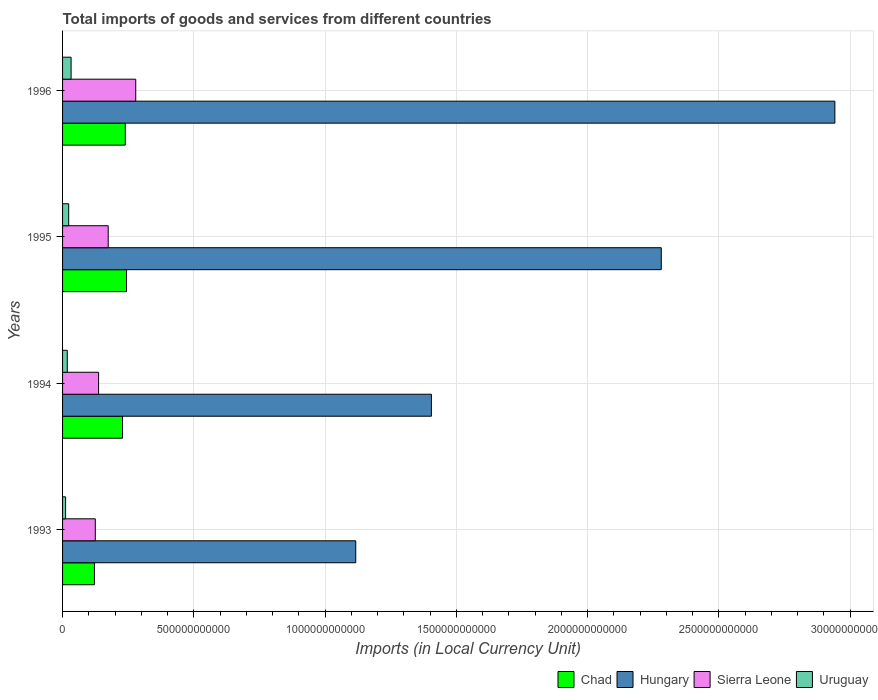How many groups of bars are there?
Provide a succinct answer. 4. Are the number of bars on each tick of the Y-axis equal?
Provide a short and direct response. Yes. How many bars are there on the 1st tick from the bottom?
Offer a terse response. 4. What is the label of the 3rd group of bars from the top?
Ensure brevity in your answer.  1994. What is the Amount of goods and services imports in Sierra Leone in 1993?
Keep it short and to the point. 1.25e+11. Across all years, what is the maximum Amount of goods and services imports in Chad?
Provide a short and direct response. 2.44e+11. Across all years, what is the minimum Amount of goods and services imports in Chad?
Your answer should be compact. 1.22e+11. In which year was the Amount of goods and services imports in Chad maximum?
Keep it short and to the point. 1995. What is the total Amount of goods and services imports in Chad in the graph?
Provide a short and direct response. 8.33e+11. What is the difference between the Amount of goods and services imports in Hungary in 1993 and that in 1995?
Offer a terse response. -1.16e+12. What is the difference between the Amount of goods and services imports in Hungary in 1996 and the Amount of goods and services imports in Uruguay in 1995?
Your answer should be very brief. 2.92e+12. What is the average Amount of goods and services imports in Uruguay per year?
Provide a succinct answer. 2.14e+1. In the year 1994, what is the difference between the Amount of goods and services imports in Uruguay and Amount of goods and services imports in Chad?
Provide a succinct answer. -2.11e+11. What is the ratio of the Amount of goods and services imports in Uruguay in 1994 to that in 1996?
Your answer should be compact. 0.55. Is the Amount of goods and services imports in Chad in 1994 less than that in 1996?
Your answer should be compact. Yes. What is the difference between the highest and the second highest Amount of goods and services imports in Chad?
Ensure brevity in your answer.  4.71e+09. What is the difference between the highest and the lowest Amount of goods and services imports in Uruguay?
Keep it short and to the point. 2.09e+1. In how many years, is the Amount of goods and services imports in Chad greater than the average Amount of goods and services imports in Chad taken over all years?
Your answer should be compact. 3. Is it the case that in every year, the sum of the Amount of goods and services imports in Sierra Leone and Amount of goods and services imports in Hungary is greater than the sum of Amount of goods and services imports in Chad and Amount of goods and services imports in Uruguay?
Make the answer very short. Yes. What does the 4th bar from the top in 1994 represents?
Provide a short and direct response. Chad. What does the 1st bar from the bottom in 1994 represents?
Ensure brevity in your answer.  Chad. What is the difference between two consecutive major ticks on the X-axis?
Provide a short and direct response. 5.00e+11. Does the graph contain any zero values?
Your response must be concise. No. Where does the legend appear in the graph?
Keep it short and to the point. Bottom right. How are the legend labels stacked?
Your answer should be very brief. Horizontal. What is the title of the graph?
Offer a very short reply. Total imports of goods and services from different countries. Does "Luxembourg" appear as one of the legend labels in the graph?
Your answer should be compact. No. What is the label or title of the X-axis?
Keep it short and to the point. Imports (in Local Currency Unit). What is the Imports (in Local Currency Unit) of Chad in 1993?
Your answer should be very brief. 1.22e+11. What is the Imports (in Local Currency Unit) in Hungary in 1993?
Ensure brevity in your answer.  1.12e+12. What is the Imports (in Local Currency Unit) in Sierra Leone in 1993?
Ensure brevity in your answer.  1.25e+11. What is the Imports (in Local Currency Unit) in Uruguay in 1993?
Offer a very short reply. 1.16e+1. What is the Imports (in Local Currency Unit) in Chad in 1994?
Ensure brevity in your answer.  2.28e+11. What is the Imports (in Local Currency Unit) in Hungary in 1994?
Your answer should be compact. 1.41e+12. What is the Imports (in Local Currency Unit) of Sierra Leone in 1994?
Your answer should be very brief. 1.37e+11. What is the Imports (in Local Currency Unit) in Uruguay in 1994?
Provide a short and direct response. 1.80e+1. What is the Imports (in Local Currency Unit) in Chad in 1995?
Provide a succinct answer. 2.44e+11. What is the Imports (in Local Currency Unit) of Hungary in 1995?
Keep it short and to the point. 2.28e+12. What is the Imports (in Local Currency Unit) of Sierra Leone in 1995?
Keep it short and to the point. 1.74e+11. What is the Imports (in Local Currency Unit) of Uruguay in 1995?
Give a very brief answer. 2.34e+1. What is the Imports (in Local Currency Unit) in Chad in 1996?
Your answer should be very brief. 2.39e+11. What is the Imports (in Local Currency Unit) in Hungary in 1996?
Your answer should be very brief. 2.94e+12. What is the Imports (in Local Currency Unit) of Sierra Leone in 1996?
Offer a very short reply. 2.79e+11. What is the Imports (in Local Currency Unit) in Uruguay in 1996?
Make the answer very short. 3.25e+1. Across all years, what is the maximum Imports (in Local Currency Unit) in Chad?
Give a very brief answer. 2.44e+11. Across all years, what is the maximum Imports (in Local Currency Unit) in Hungary?
Make the answer very short. 2.94e+12. Across all years, what is the maximum Imports (in Local Currency Unit) of Sierra Leone?
Make the answer very short. 2.79e+11. Across all years, what is the maximum Imports (in Local Currency Unit) in Uruguay?
Provide a short and direct response. 3.25e+1. Across all years, what is the minimum Imports (in Local Currency Unit) of Chad?
Ensure brevity in your answer.  1.22e+11. Across all years, what is the minimum Imports (in Local Currency Unit) in Hungary?
Make the answer very short. 1.12e+12. Across all years, what is the minimum Imports (in Local Currency Unit) of Sierra Leone?
Offer a very short reply. 1.25e+11. Across all years, what is the minimum Imports (in Local Currency Unit) in Uruguay?
Your answer should be very brief. 1.16e+1. What is the total Imports (in Local Currency Unit) of Chad in the graph?
Your answer should be very brief. 8.33e+11. What is the total Imports (in Local Currency Unit) in Hungary in the graph?
Ensure brevity in your answer.  7.75e+12. What is the total Imports (in Local Currency Unit) of Sierra Leone in the graph?
Ensure brevity in your answer.  7.15e+11. What is the total Imports (in Local Currency Unit) of Uruguay in the graph?
Offer a very short reply. 8.54e+1. What is the difference between the Imports (in Local Currency Unit) in Chad in 1993 and that in 1994?
Make the answer very short. -1.07e+11. What is the difference between the Imports (in Local Currency Unit) in Hungary in 1993 and that in 1994?
Give a very brief answer. -2.88e+11. What is the difference between the Imports (in Local Currency Unit) of Sierra Leone in 1993 and that in 1994?
Offer a terse response. -1.25e+1. What is the difference between the Imports (in Local Currency Unit) of Uruguay in 1993 and that in 1994?
Provide a succinct answer. -6.40e+09. What is the difference between the Imports (in Local Currency Unit) of Chad in 1993 and that in 1995?
Offer a terse response. -1.22e+11. What is the difference between the Imports (in Local Currency Unit) of Hungary in 1993 and that in 1995?
Provide a short and direct response. -1.16e+12. What is the difference between the Imports (in Local Currency Unit) of Sierra Leone in 1993 and that in 1995?
Give a very brief answer. -4.92e+1. What is the difference between the Imports (in Local Currency Unit) in Uruguay in 1993 and that in 1995?
Keep it short and to the point. -1.18e+1. What is the difference between the Imports (in Local Currency Unit) of Chad in 1993 and that in 1996?
Provide a short and direct response. -1.17e+11. What is the difference between the Imports (in Local Currency Unit) in Hungary in 1993 and that in 1996?
Your answer should be very brief. -1.83e+12. What is the difference between the Imports (in Local Currency Unit) of Sierra Leone in 1993 and that in 1996?
Your answer should be compact. -1.54e+11. What is the difference between the Imports (in Local Currency Unit) in Uruguay in 1993 and that in 1996?
Make the answer very short. -2.09e+1. What is the difference between the Imports (in Local Currency Unit) in Chad in 1994 and that in 1995?
Offer a terse response. -1.52e+1. What is the difference between the Imports (in Local Currency Unit) in Hungary in 1994 and that in 1995?
Ensure brevity in your answer.  -8.76e+11. What is the difference between the Imports (in Local Currency Unit) of Sierra Leone in 1994 and that in 1995?
Offer a very short reply. -3.66e+1. What is the difference between the Imports (in Local Currency Unit) in Uruguay in 1994 and that in 1995?
Your answer should be compact. -5.44e+09. What is the difference between the Imports (in Local Currency Unit) in Chad in 1994 and that in 1996?
Your response must be concise. -1.05e+1. What is the difference between the Imports (in Local Currency Unit) in Hungary in 1994 and that in 1996?
Your response must be concise. -1.54e+12. What is the difference between the Imports (in Local Currency Unit) of Sierra Leone in 1994 and that in 1996?
Your answer should be compact. -1.42e+11. What is the difference between the Imports (in Local Currency Unit) in Uruguay in 1994 and that in 1996?
Make the answer very short. -1.45e+1. What is the difference between the Imports (in Local Currency Unit) in Chad in 1995 and that in 1996?
Provide a short and direct response. 4.71e+09. What is the difference between the Imports (in Local Currency Unit) of Hungary in 1995 and that in 1996?
Your answer should be compact. -6.61e+11. What is the difference between the Imports (in Local Currency Unit) of Sierra Leone in 1995 and that in 1996?
Offer a terse response. -1.05e+11. What is the difference between the Imports (in Local Currency Unit) in Uruguay in 1995 and that in 1996?
Ensure brevity in your answer.  -9.08e+09. What is the difference between the Imports (in Local Currency Unit) of Chad in 1993 and the Imports (in Local Currency Unit) of Hungary in 1994?
Your answer should be very brief. -1.28e+12. What is the difference between the Imports (in Local Currency Unit) of Chad in 1993 and the Imports (in Local Currency Unit) of Sierra Leone in 1994?
Your response must be concise. -1.57e+1. What is the difference between the Imports (in Local Currency Unit) in Chad in 1993 and the Imports (in Local Currency Unit) in Uruguay in 1994?
Make the answer very short. 1.04e+11. What is the difference between the Imports (in Local Currency Unit) in Hungary in 1993 and the Imports (in Local Currency Unit) in Sierra Leone in 1994?
Ensure brevity in your answer.  9.80e+11. What is the difference between the Imports (in Local Currency Unit) in Hungary in 1993 and the Imports (in Local Currency Unit) in Uruguay in 1994?
Your answer should be very brief. 1.10e+12. What is the difference between the Imports (in Local Currency Unit) of Sierra Leone in 1993 and the Imports (in Local Currency Unit) of Uruguay in 1994?
Your answer should be very brief. 1.07e+11. What is the difference between the Imports (in Local Currency Unit) in Chad in 1993 and the Imports (in Local Currency Unit) in Hungary in 1995?
Offer a terse response. -2.16e+12. What is the difference between the Imports (in Local Currency Unit) of Chad in 1993 and the Imports (in Local Currency Unit) of Sierra Leone in 1995?
Give a very brief answer. -5.24e+1. What is the difference between the Imports (in Local Currency Unit) of Chad in 1993 and the Imports (in Local Currency Unit) of Uruguay in 1995?
Offer a terse response. 9.81e+1. What is the difference between the Imports (in Local Currency Unit) of Hungary in 1993 and the Imports (in Local Currency Unit) of Sierra Leone in 1995?
Ensure brevity in your answer.  9.43e+11. What is the difference between the Imports (in Local Currency Unit) in Hungary in 1993 and the Imports (in Local Currency Unit) in Uruguay in 1995?
Your response must be concise. 1.09e+12. What is the difference between the Imports (in Local Currency Unit) in Sierra Leone in 1993 and the Imports (in Local Currency Unit) in Uruguay in 1995?
Make the answer very short. 1.01e+11. What is the difference between the Imports (in Local Currency Unit) of Chad in 1993 and the Imports (in Local Currency Unit) of Hungary in 1996?
Your response must be concise. -2.82e+12. What is the difference between the Imports (in Local Currency Unit) in Chad in 1993 and the Imports (in Local Currency Unit) in Sierra Leone in 1996?
Your answer should be very brief. -1.57e+11. What is the difference between the Imports (in Local Currency Unit) in Chad in 1993 and the Imports (in Local Currency Unit) in Uruguay in 1996?
Keep it short and to the point. 8.90e+1. What is the difference between the Imports (in Local Currency Unit) in Hungary in 1993 and the Imports (in Local Currency Unit) in Sierra Leone in 1996?
Your answer should be very brief. 8.38e+11. What is the difference between the Imports (in Local Currency Unit) in Hungary in 1993 and the Imports (in Local Currency Unit) in Uruguay in 1996?
Offer a terse response. 1.08e+12. What is the difference between the Imports (in Local Currency Unit) of Sierra Leone in 1993 and the Imports (in Local Currency Unit) of Uruguay in 1996?
Provide a short and direct response. 9.22e+1. What is the difference between the Imports (in Local Currency Unit) of Chad in 1994 and the Imports (in Local Currency Unit) of Hungary in 1995?
Your answer should be very brief. -2.05e+12. What is the difference between the Imports (in Local Currency Unit) of Chad in 1994 and the Imports (in Local Currency Unit) of Sierra Leone in 1995?
Give a very brief answer. 5.46e+1. What is the difference between the Imports (in Local Currency Unit) of Chad in 1994 and the Imports (in Local Currency Unit) of Uruguay in 1995?
Give a very brief answer. 2.05e+11. What is the difference between the Imports (in Local Currency Unit) in Hungary in 1994 and the Imports (in Local Currency Unit) in Sierra Leone in 1995?
Provide a succinct answer. 1.23e+12. What is the difference between the Imports (in Local Currency Unit) of Hungary in 1994 and the Imports (in Local Currency Unit) of Uruguay in 1995?
Make the answer very short. 1.38e+12. What is the difference between the Imports (in Local Currency Unit) of Sierra Leone in 1994 and the Imports (in Local Currency Unit) of Uruguay in 1995?
Keep it short and to the point. 1.14e+11. What is the difference between the Imports (in Local Currency Unit) in Chad in 1994 and the Imports (in Local Currency Unit) in Hungary in 1996?
Provide a short and direct response. -2.71e+12. What is the difference between the Imports (in Local Currency Unit) in Chad in 1994 and the Imports (in Local Currency Unit) in Sierra Leone in 1996?
Offer a terse response. -5.03e+1. What is the difference between the Imports (in Local Currency Unit) of Chad in 1994 and the Imports (in Local Currency Unit) of Uruguay in 1996?
Provide a short and direct response. 1.96e+11. What is the difference between the Imports (in Local Currency Unit) of Hungary in 1994 and the Imports (in Local Currency Unit) of Sierra Leone in 1996?
Ensure brevity in your answer.  1.13e+12. What is the difference between the Imports (in Local Currency Unit) in Hungary in 1994 and the Imports (in Local Currency Unit) in Uruguay in 1996?
Ensure brevity in your answer.  1.37e+12. What is the difference between the Imports (in Local Currency Unit) of Sierra Leone in 1994 and the Imports (in Local Currency Unit) of Uruguay in 1996?
Keep it short and to the point. 1.05e+11. What is the difference between the Imports (in Local Currency Unit) in Chad in 1995 and the Imports (in Local Currency Unit) in Hungary in 1996?
Provide a short and direct response. -2.70e+12. What is the difference between the Imports (in Local Currency Unit) in Chad in 1995 and the Imports (in Local Currency Unit) in Sierra Leone in 1996?
Make the answer very short. -3.51e+1. What is the difference between the Imports (in Local Currency Unit) in Chad in 1995 and the Imports (in Local Currency Unit) in Uruguay in 1996?
Provide a short and direct response. 2.11e+11. What is the difference between the Imports (in Local Currency Unit) of Hungary in 1995 and the Imports (in Local Currency Unit) of Sierra Leone in 1996?
Offer a terse response. 2.00e+12. What is the difference between the Imports (in Local Currency Unit) of Hungary in 1995 and the Imports (in Local Currency Unit) of Uruguay in 1996?
Keep it short and to the point. 2.25e+12. What is the difference between the Imports (in Local Currency Unit) in Sierra Leone in 1995 and the Imports (in Local Currency Unit) in Uruguay in 1996?
Keep it short and to the point. 1.41e+11. What is the average Imports (in Local Currency Unit) in Chad per year?
Your response must be concise. 2.08e+11. What is the average Imports (in Local Currency Unit) of Hungary per year?
Give a very brief answer. 1.94e+12. What is the average Imports (in Local Currency Unit) in Sierra Leone per year?
Offer a terse response. 1.79e+11. What is the average Imports (in Local Currency Unit) of Uruguay per year?
Your answer should be compact. 2.14e+1. In the year 1993, what is the difference between the Imports (in Local Currency Unit) in Chad and Imports (in Local Currency Unit) in Hungary?
Give a very brief answer. -9.95e+11. In the year 1993, what is the difference between the Imports (in Local Currency Unit) of Chad and Imports (in Local Currency Unit) of Sierra Leone?
Provide a succinct answer. -3.18e+09. In the year 1993, what is the difference between the Imports (in Local Currency Unit) of Chad and Imports (in Local Currency Unit) of Uruguay?
Keep it short and to the point. 1.10e+11. In the year 1993, what is the difference between the Imports (in Local Currency Unit) in Hungary and Imports (in Local Currency Unit) in Sierra Leone?
Provide a short and direct response. 9.92e+11. In the year 1993, what is the difference between the Imports (in Local Currency Unit) in Hungary and Imports (in Local Currency Unit) in Uruguay?
Provide a short and direct response. 1.11e+12. In the year 1993, what is the difference between the Imports (in Local Currency Unit) of Sierra Leone and Imports (in Local Currency Unit) of Uruguay?
Offer a very short reply. 1.13e+11. In the year 1994, what is the difference between the Imports (in Local Currency Unit) in Chad and Imports (in Local Currency Unit) in Hungary?
Your response must be concise. -1.18e+12. In the year 1994, what is the difference between the Imports (in Local Currency Unit) in Chad and Imports (in Local Currency Unit) in Sierra Leone?
Keep it short and to the point. 9.13e+1. In the year 1994, what is the difference between the Imports (in Local Currency Unit) of Chad and Imports (in Local Currency Unit) of Uruguay?
Offer a terse response. 2.11e+11. In the year 1994, what is the difference between the Imports (in Local Currency Unit) in Hungary and Imports (in Local Currency Unit) in Sierra Leone?
Provide a short and direct response. 1.27e+12. In the year 1994, what is the difference between the Imports (in Local Currency Unit) of Hungary and Imports (in Local Currency Unit) of Uruguay?
Your response must be concise. 1.39e+12. In the year 1994, what is the difference between the Imports (in Local Currency Unit) in Sierra Leone and Imports (in Local Currency Unit) in Uruguay?
Provide a short and direct response. 1.19e+11. In the year 1995, what is the difference between the Imports (in Local Currency Unit) of Chad and Imports (in Local Currency Unit) of Hungary?
Provide a succinct answer. -2.04e+12. In the year 1995, what is the difference between the Imports (in Local Currency Unit) in Chad and Imports (in Local Currency Unit) in Sierra Leone?
Your answer should be compact. 6.98e+1. In the year 1995, what is the difference between the Imports (in Local Currency Unit) in Chad and Imports (in Local Currency Unit) in Uruguay?
Keep it short and to the point. 2.20e+11. In the year 1995, what is the difference between the Imports (in Local Currency Unit) in Hungary and Imports (in Local Currency Unit) in Sierra Leone?
Offer a very short reply. 2.11e+12. In the year 1995, what is the difference between the Imports (in Local Currency Unit) in Hungary and Imports (in Local Currency Unit) in Uruguay?
Your response must be concise. 2.26e+12. In the year 1995, what is the difference between the Imports (in Local Currency Unit) in Sierra Leone and Imports (in Local Currency Unit) in Uruguay?
Offer a very short reply. 1.50e+11. In the year 1996, what is the difference between the Imports (in Local Currency Unit) of Chad and Imports (in Local Currency Unit) of Hungary?
Provide a short and direct response. -2.70e+12. In the year 1996, what is the difference between the Imports (in Local Currency Unit) in Chad and Imports (in Local Currency Unit) in Sierra Leone?
Keep it short and to the point. -3.98e+1. In the year 1996, what is the difference between the Imports (in Local Currency Unit) in Chad and Imports (in Local Currency Unit) in Uruguay?
Offer a terse response. 2.07e+11. In the year 1996, what is the difference between the Imports (in Local Currency Unit) of Hungary and Imports (in Local Currency Unit) of Sierra Leone?
Your answer should be compact. 2.66e+12. In the year 1996, what is the difference between the Imports (in Local Currency Unit) of Hungary and Imports (in Local Currency Unit) of Uruguay?
Offer a terse response. 2.91e+12. In the year 1996, what is the difference between the Imports (in Local Currency Unit) of Sierra Leone and Imports (in Local Currency Unit) of Uruguay?
Your response must be concise. 2.46e+11. What is the ratio of the Imports (in Local Currency Unit) of Chad in 1993 to that in 1994?
Offer a very short reply. 0.53. What is the ratio of the Imports (in Local Currency Unit) of Hungary in 1993 to that in 1994?
Keep it short and to the point. 0.79. What is the ratio of the Imports (in Local Currency Unit) in Sierra Leone in 1993 to that in 1994?
Offer a terse response. 0.91. What is the ratio of the Imports (in Local Currency Unit) of Uruguay in 1993 to that in 1994?
Provide a short and direct response. 0.64. What is the ratio of the Imports (in Local Currency Unit) in Chad in 1993 to that in 1995?
Ensure brevity in your answer.  0.5. What is the ratio of the Imports (in Local Currency Unit) of Hungary in 1993 to that in 1995?
Offer a very short reply. 0.49. What is the ratio of the Imports (in Local Currency Unit) in Sierra Leone in 1993 to that in 1995?
Your answer should be very brief. 0.72. What is the ratio of the Imports (in Local Currency Unit) in Uruguay in 1993 to that in 1995?
Provide a short and direct response. 0.49. What is the ratio of the Imports (in Local Currency Unit) of Chad in 1993 to that in 1996?
Make the answer very short. 0.51. What is the ratio of the Imports (in Local Currency Unit) of Hungary in 1993 to that in 1996?
Offer a terse response. 0.38. What is the ratio of the Imports (in Local Currency Unit) of Sierra Leone in 1993 to that in 1996?
Provide a succinct answer. 0.45. What is the ratio of the Imports (in Local Currency Unit) in Uruguay in 1993 to that in 1996?
Keep it short and to the point. 0.36. What is the ratio of the Imports (in Local Currency Unit) in Chad in 1994 to that in 1995?
Offer a very short reply. 0.94. What is the ratio of the Imports (in Local Currency Unit) of Hungary in 1994 to that in 1995?
Provide a succinct answer. 0.62. What is the ratio of the Imports (in Local Currency Unit) of Sierra Leone in 1994 to that in 1995?
Keep it short and to the point. 0.79. What is the ratio of the Imports (in Local Currency Unit) in Uruguay in 1994 to that in 1995?
Ensure brevity in your answer.  0.77. What is the ratio of the Imports (in Local Currency Unit) in Chad in 1994 to that in 1996?
Your answer should be compact. 0.96. What is the ratio of the Imports (in Local Currency Unit) in Hungary in 1994 to that in 1996?
Your answer should be very brief. 0.48. What is the ratio of the Imports (in Local Currency Unit) of Sierra Leone in 1994 to that in 1996?
Offer a very short reply. 0.49. What is the ratio of the Imports (in Local Currency Unit) in Uruguay in 1994 to that in 1996?
Offer a terse response. 0.55. What is the ratio of the Imports (in Local Currency Unit) of Chad in 1995 to that in 1996?
Provide a short and direct response. 1.02. What is the ratio of the Imports (in Local Currency Unit) of Hungary in 1995 to that in 1996?
Give a very brief answer. 0.78. What is the ratio of the Imports (in Local Currency Unit) of Sierra Leone in 1995 to that in 1996?
Offer a terse response. 0.62. What is the ratio of the Imports (in Local Currency Unit) of Uruguay in 1995 to that in 1996?
Ensure brevity in your answer.  0.72. What is the difference between the highest and the second highest Imports (in Local Currency Unit) in Chad?
Your answer should be compact. 4.71e+09. What is the difference between the highest and the second highest Imports (in Local Currency Unit) of Hungary?
Offer a very short reply. 6.61e+11. What is the difference between the highest and the second highest Imports (in Local Currency Unit) in Sierra Leone?
Keep it short and to the point. 1.05e+11. What is the difference between the highest and the second highest Imports (in Local Currency Unit) in Uruguay?
Provide a short and direct response. 9.08e+09. What is the difference between the highest and the lowest Imports (in Local Currency Unit) of Chad?
Give a very brief answer. 1.22e+11. What is the difference between the highest and the lowest Imports (in Local Currency Unit) in Hungary?
Provide a short and direct response. 1.83e+12. What is the difference between the highest and the lowest Imports (in Local Currency Unit) of Sierra Leone?
Your response must be concise. 1.54e+11. What is the difference between the highest and the lowest Imports (in Local Currency Unit) of Uruguay?
Provide a short and direct response. 2.09e+1. 